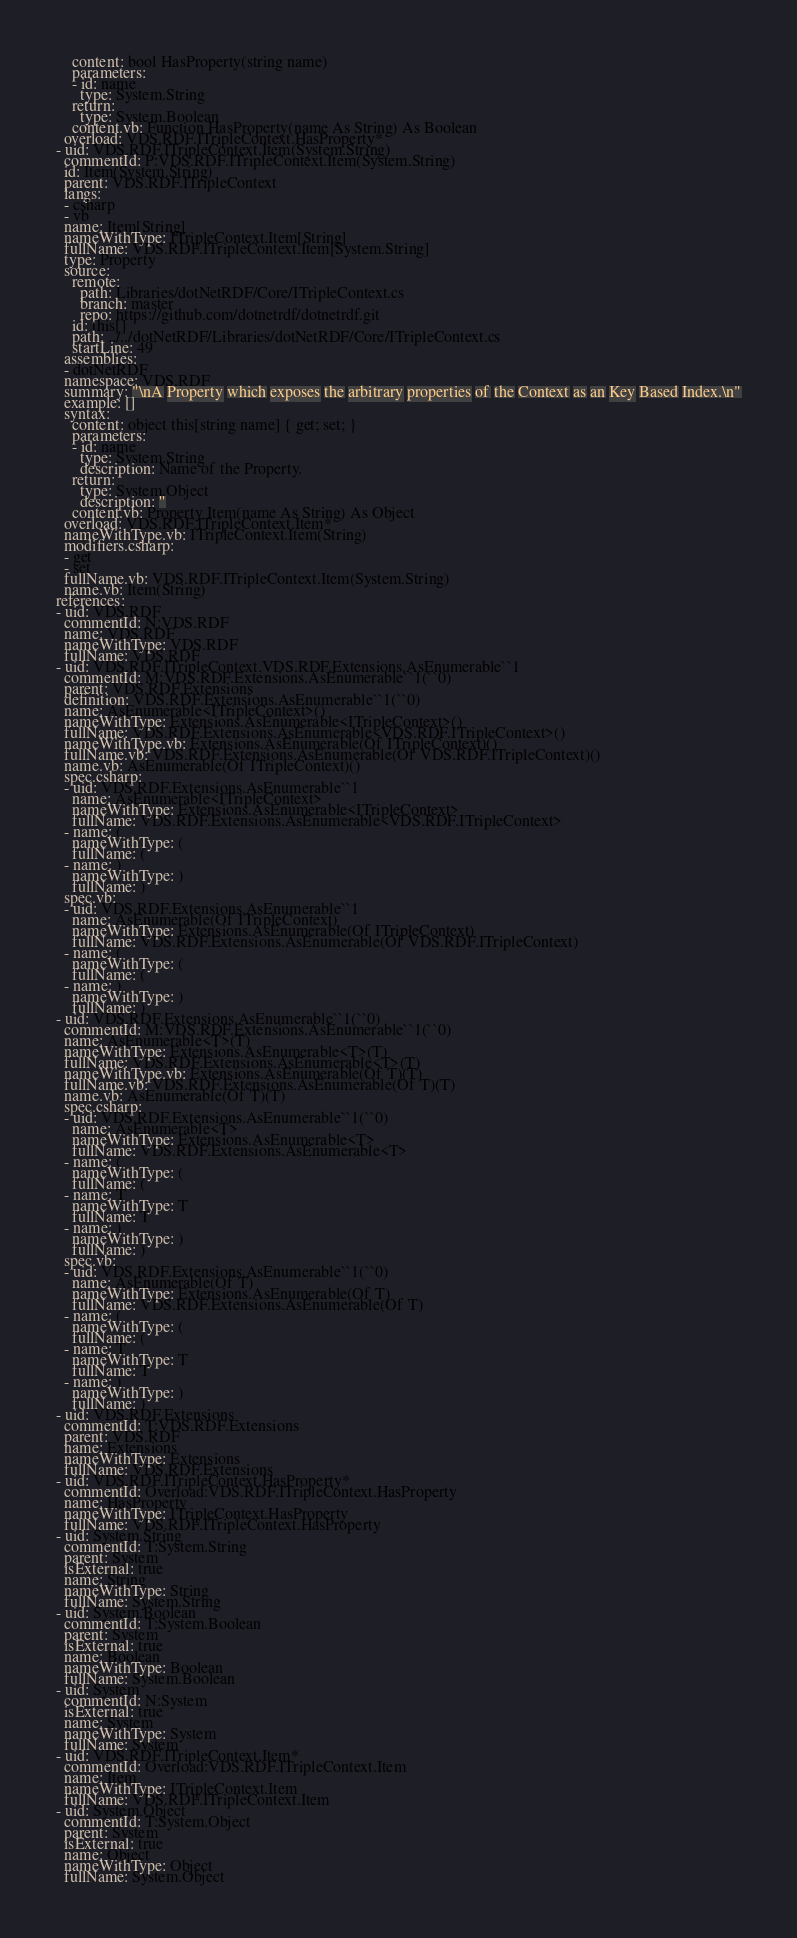Convert code to text. <code><loc_0><loc_0><loc_500><loc_500><_YAML_>    content: bool HasProperty(string name)
    parameters:
    - id: name
      type: System.String
    return:
      type: System.Boolean
    content.vb: Function HasProperty(name As String) As Boolean
  overload: VDS.RDF.ITripleContext.HasProperty*
- uid: VDS.RDF.ITripleContext.Item(System.String)
  commentId: P:VDS.RDF.ITripleContext.Item(System.String)
  id: Item(System.String)
  parent: VDS.RDF.ITripleContext
  langs:
  - csharp
  - vb
  name: Item[String]
  nameWithType: ITripleContext.Item[String]
  fullName: VDS.RDF.ITripleContext.Item[System.String]
  type: Property
  source:
    remote:
      path: Libraries/dotNetRDF/Core/ITripleContext.cs
      branch: master
      repo: https://github.com/dotnetrdf/dotnetrdf.git
    id: this[]
    path: ../../dotNetRDF/Libraries/dotNetRDF/Core/ITripleContext.cs
    startLine: 49
  assemblies:
  - dotNetRDF
  namespace: VDS.RDF
  summary: "\nA Property which exposes the arbitrary properties of the Context as an Key Based Index.\n"
  example: []
  syntax:
    content: object this[string name] { get; set; }
    parameters:
    - id: name
      type: System.String
      description: Name of the Property.
    return:
      type: System.Object
      description: ''
    content.vb: Property Item(name As String) As Object
  overload: VDS.RDF.ITripleContext.Item*
  nameWithType.vb: ITripleContext.Item(String)
  modifiers.csharp:
  - get
  - set
  fullName.vb: VDS.RDF.ITripleContext.Item(System.String)
  name.vb: Item(String)
references:
- uid: VDS.RDF
  commentId: N:VDS.RDF
  name: VDS.RDF
  nameWithType: VDS.RDF
  fullName: VDS.RDF
- uid: VDS.RDF.ITripleContext.VDS.RDF.Extensions.AsEnumerable``1
  commentId: M:VDS.RDF.Extensions.AsEnumerable``1(``0)
  parent: VDS.RDF.Extensions
  definition: VDS.RDF.Extensions.AsEnumerable``1(``0)
  name: AsEnumerable<ITripleContext>()
  nameWithType: Extensions.AsEnumerable<ITripleContext>()
  fullName: VDS.RDF.Extensions.AsEnumerable<VDS.RDF.ITripleContext>()
  nameWithType.vb: Extensions.AsEnumerable(Of ITripleContext)()
  fullName.vb: VDS.RDF.Extensions.AsEnumerable(Of VDS.RDF.ITripleContext)()
  name.vb: AsEnumerable(Of ITripleContext)()
  spec.csharp:
  - uid: VDS.RDF.Extensions.AsEnumerable``1
    name: AsEnumerable<ITripleContext>
    nameWithType: Extensions.AsEnumerable<ITripleContext>
    fullName: VDS.RDF.Extensions.AsEnumerable<VDS.RDF.ITripleContext>
  - name: (
    nameWithType: (
    fullName: (
  - name: )
    nameWithType: )
    fullName: )
  spec.vb:
  - uid: VDS.RDF.Extensions.AsEnumerable``1
    name: AsEnumerable(Of ITripleContext)
    nameWithType: Extensions.AsEnumerable(Of ITripleContext)
    fullName: VDS.RDF.Extensions.AsEnumerable(Of VDS.RDF.ITripleContext)
  - name: (
    nameWithType: (
    fullName: (
  - name: )
    nameWithType: )
    fullName: )
- uid: VDS.RDF.Extensions.AsEnumerable``1(``0)
  commentId: M:VDS.RDF.Extensions.AsEnumerable``1(``0)
  name: AsEnumerable<T>(T)
  nameWithType: Extensions.AsEnumerable<T>(T)
  fullName: VDS.RDF.Extensions.AsEnumerable<T>(T)
  nameWithType.vb: Extensions.AsEnumerable(Of T)(T)
  fullName.vb: VDS.RDF.Extensions.AsEnumerable(Of T)(T)
  name.vb: AsEnumerable(Of T)(T)
  spec.csharp:
  - uid: VDS.RDF.Extensions.AsEnumerable``1(``0)
    name: AsEnumerable<T>
    nameWithType: Extensions.AsEnumerable<T>
    fullName: VDS.RDF.Extensions.AsEnumerable<T>
  - name: (
    nameWithType: (
    fullName: (
  - name: T
    nameWithType: T
    fullName: T
  - name: )
    nameWithType: )
    fullName: )
  spec.vb:
  - uid: VDS.RDF.Extensions.AsEnumerable``1(``0)
    name: AsEnumerable(Of T)
    nameWithType: Extensions.AsEnumerable(Of T)
    fullName: VDS.RDF.Extensions.AsEnumerable(Of T)
  - name: (
    nameWithType: (
    fullName: (
  - name: T
    nameWithType: T
    fullName: T
  - name: )
    nameWithType: )
    fullName: )
- uid: VDS.RDF.Extensions
  commentId: T:VDS.RDF.Extensions
  parent: VDS.RDF
  name: Extensions
  nameWithType: Extensions
  fullName: VDS.RDF.Extensions
- uid: VDS.RDF.ITripleContext.HasProperty*
  commentId: Overload:VDS.RDF.ITripleContext.HasProperty
  name: HasProperty
  nameWithType: ITripleContext.HasProperty
  fullName: VDS.RDF.ITripleContext.HasProperty
- uid: System.String
  commentId: T:System.String
  parent: System
  isExternal: true
  name: String
  nameWithType: String
  fullName: System.String
- uid: System.Boolean
  commentId: T:System.Boolean
  parent: System
  isExternal: true
  name: Boolean
  nameWithType: Boolean
  fullName: System.Boolean
- uid: System
  commentId: N:System
  isExternal: true
  name: System
  nameWithType: System
  fullName: System
- uid: VDS.RDF.ITripleContext.Item*
  commentId: Overload:VDS.RDF.ITripleContext.Item
  name: Item
  nameWithType: ITripleContext.Item
  fullName: VDS.RDF.ITripleContext.Item
- uid: System.Object
  commentId: T:System.Object
  parent: System
  isExternal: true
  name: Object
  nameWithType: Object
  fullName: System.Object
</code> 